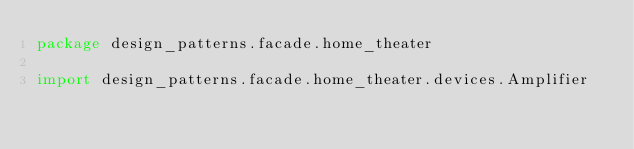Convert code to text. <code><loc_0><loc_0><loc_500><loc_500><_Kotlin_>package design_patterns.facade.home_theater

import design_patterns.facade.home_theater.devices.Amplifier</code> 